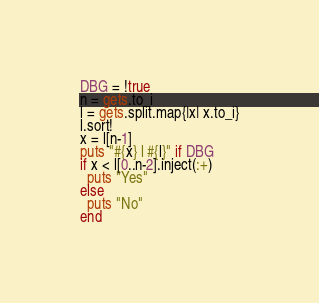Convert code to text. <code><loc_0><loc_0><loc_500><loc_500><_Ruby_>DBG = !true
n = gets.to_i
l = gets.split.map{|x| x.to_i}
l.sort!
x = l[n-1]
puts "#{x} l #{l}" if DBG
if x < l[0..n-2].inject(:+)
  puts "Yes"
else
  puts "No"
end
</code> 